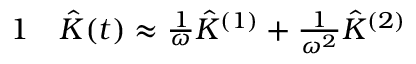<formula> <loc_0><loc_0><loc_500><loc_500>\begin{array} { r l } { 1 } & \hat { K } ( t ) \approx \frac { 1 } { \omega } \hat { K } ^ { ( 1 ) } + \frac { 1 } { \omega ^ { 2 } } \hat { K } ^ { ( 2 ) } } \end{array}</formula> 